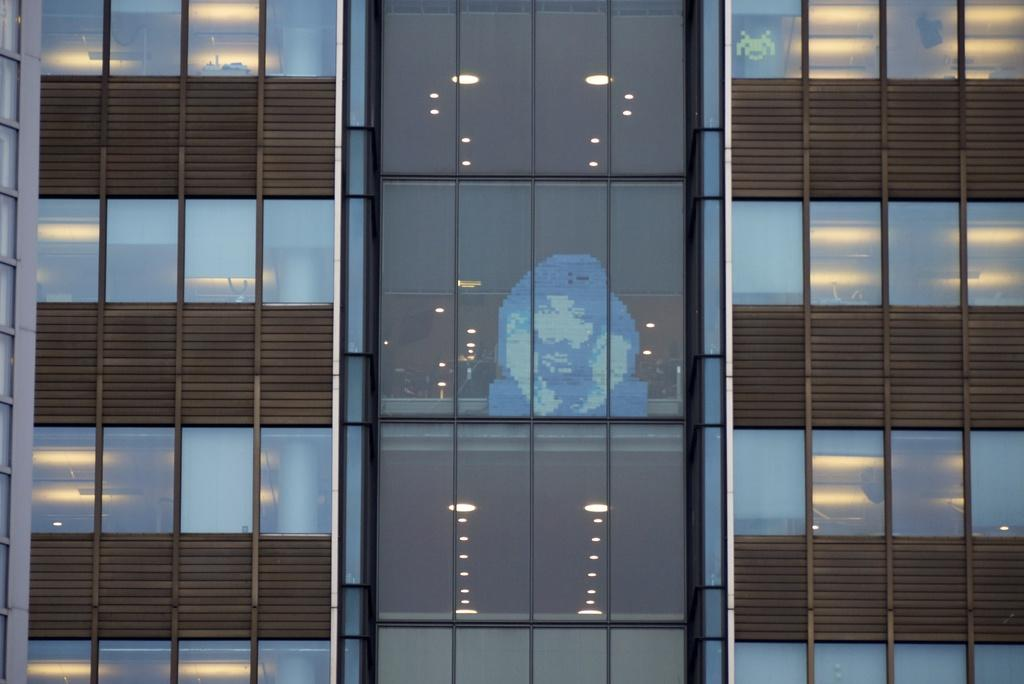What type of structure is present in the image? There is a building in the image. What feature can be observed on the building? The building has glass windows. Can you describe the roof of the building? There is a light arrangement on the roof of the building. How many oranges are being cared for by the bean in the image? There are no oranges or beans present in the image. 